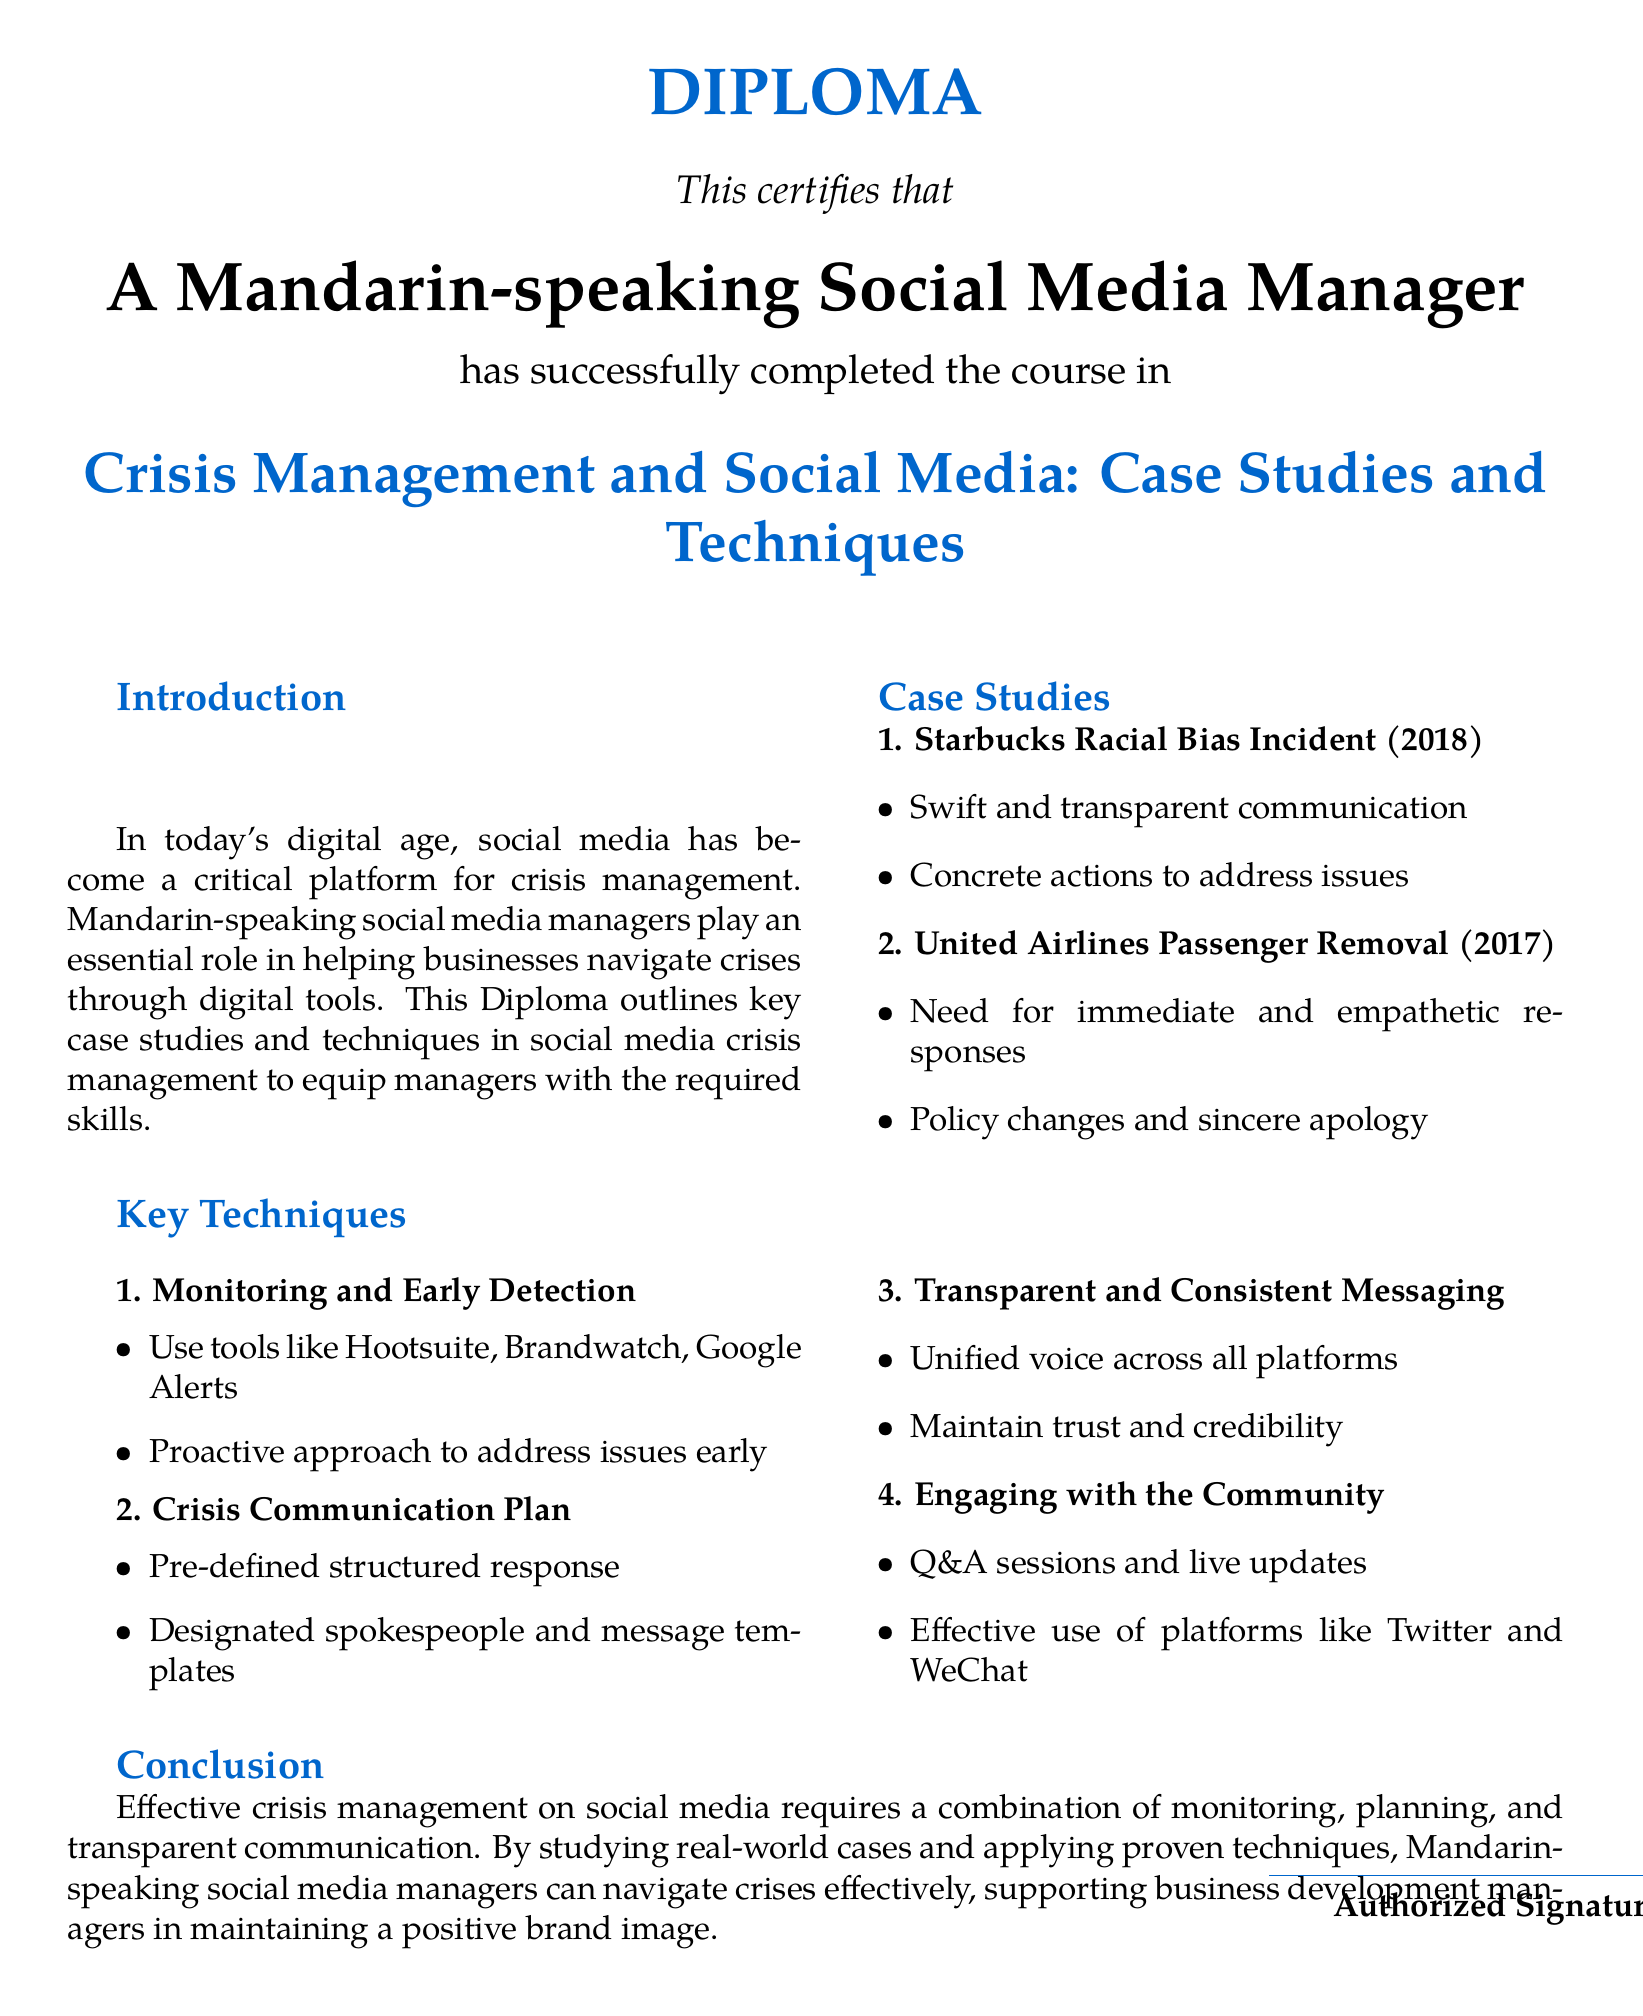what is the title of the diploma? The title is stated prominently in the document and is "Crisis Management and Social Media: Case Studies and Techniques."
Answer: Crisis Management and Social Media: Case Studies and Techniques who completed the course? The document specifies who has completed the course, which is "A Mandarin-speaking Social Media Manager."
Answer: A Mandarin-speaking Social Media Manager how many case studies are mentioned? The document lists two specific case studies under the Case Studies section, which can be counted directly.
Answer: 2 what year did the Starbucks racial bias incident occur? The document provides a specific year for this incident, which is mentioned in the case study description.
Answer: 2018 what is one key technique in crisis management? The document lists several key techniques, and one can be found in the Key Techniques section.
Answer: Monitoring and Early Detection which platform is specifically mentioned for community engagement? The document discusses specific platforms used for community engagement in the Key Techniques section.
Answer: Twitter and WeChat what type of approach should be taken for monitoring? The document emphasizes a proactive approach as part of the techniques discussed.
Answer: Proactive approach what is the purpose of a crisis communication plan? The document describes the plan's purpose to ensure a structured response during a crisis.
Answer: Structured response who signs the diploma? The document indicates there is a space for a signature, noted as "Authorized Signature."
Answer: Authorized Signature 